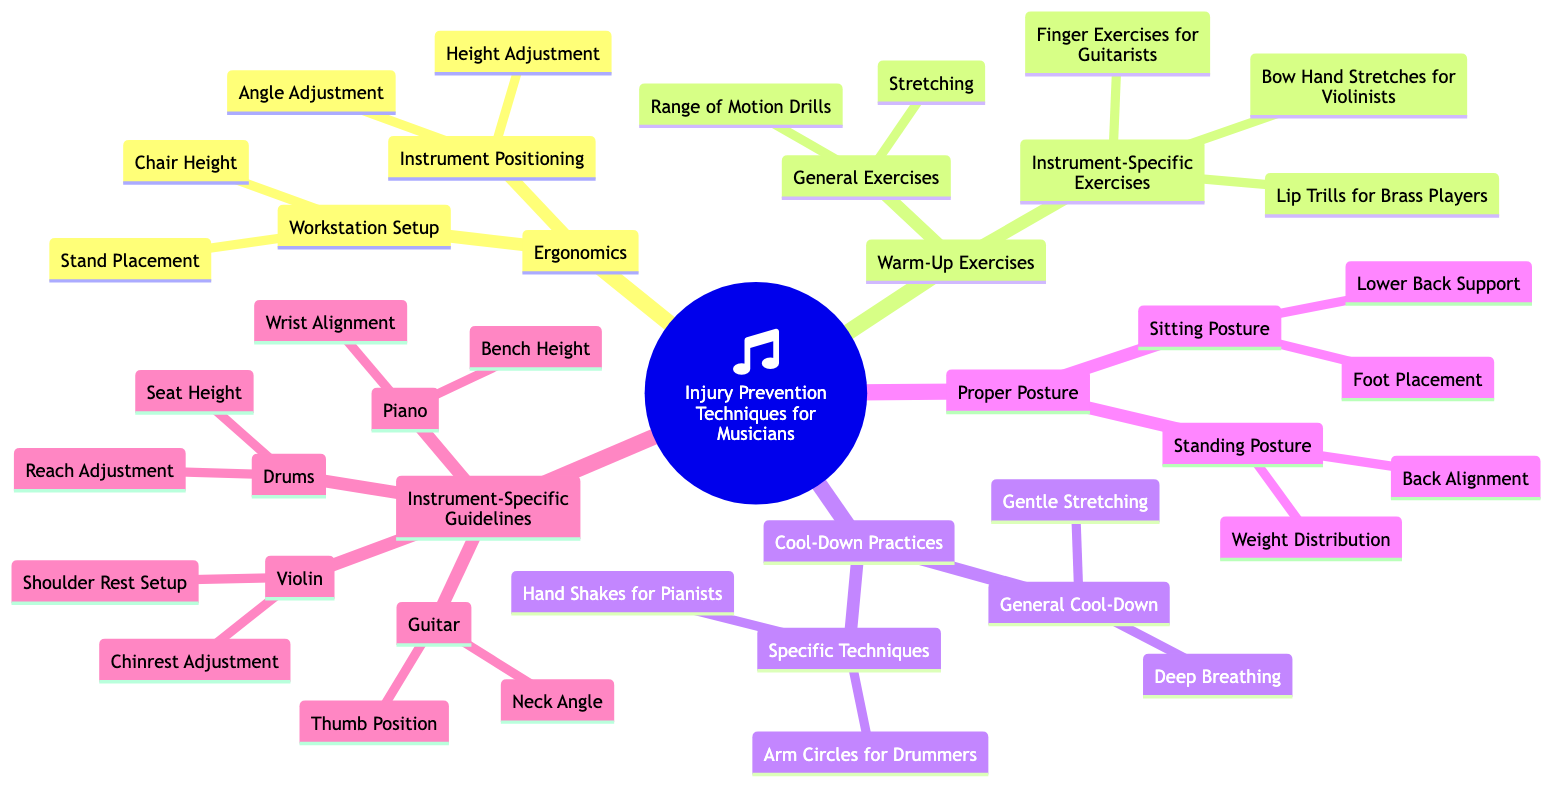What are the two main categories under Ergonomics? The diagram indicates that Ergonomics has two main categories: Instrument Positioning and Workstation Setup. These categories serve different purposes within the broader context of injury prevention for musicians.
Answer: Instrument Positioning, Workstation Setup How many exercises are listed for Instrument-Specific Exercises? Under Warm-Up Exercises, the section for Instrument-Specific Exercises includes three specific exercises: Finger Exercises for Guitarists, Lip Trills for Brass Players, and Bow Hand Stretches for Violinists. Counting these gives a total of three exercises.
Answer: 3 What is the primary focus of Cool-Down Practices? The Cool-Down Practices section includes techniques such as Gentle Stretching and Deep Breathing, which are aimed at relaxation and recovery after playing. This indicates that the primary focus is on recovery methods.
Answer: Recovery Which two factors are listed under Proper Sitting Posture? The Proper Posture section details two factors specifically mentioned under Sitting Posture: Lower Back Support and Foot Placement. This indicates they are key to maintaining proper posture while seated.
Answer: Lower Back Support, Foot Placement How many guidelines are provided for the instrument Piano? In the Instrument-Specific Guidelines section, two specific guidelines are mentioned for Piano: Wrist Alignment and Bench Height. This shows the focus on ensuring correct positioning for pianists.
Answer: 2 Which exercise is specific for Drummers in the Cool-Down Practices? The Specific Techniques under Cool-Down Practices include Arm Circles for Drummers. This exercise is tailored to address the unique movements drummers use and helps in their cool-down routine.
Answer: Arm Circles What ergonomic adjustments are recommended for Guitarists? Under Instrument-Specific Guidelines for Guitar, two adjustments are highlighted: Thumb Position and Neck Angle. These adjustments are crucial for ensuring proper technique and comfort while playing the guitar.
Answer: Thumb Position, Neck Angle What type of stretching is recommended as a General Cool-Down? The diagram identifies Gentle Stretching as a General Cool-Down practice. This type of stretching is beneficial after a performance or practice session to ease muscle tension.
Answer: Gentle Stretching 